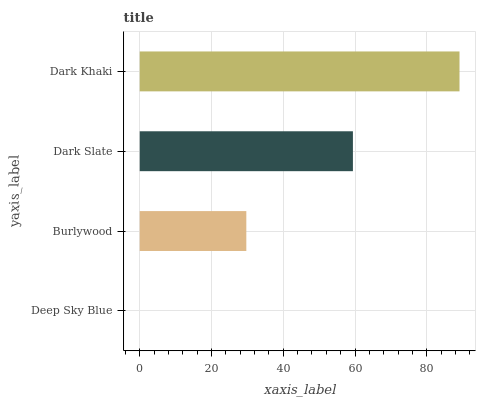Is Deep Sky Blue the minimum?
Answer yes or no. Yes. Is Dark Khaki the maximum?
Answer yes or no. Yes. Is Burlywood the minimum?
Answer yes or no. No. Is Burlywood the maximum?
Answer yes or no. No. Is Burlywood greater than Deep Sky Blue?
Answer yes or no. Yes. Is Deep Sky Blue less than Burlywood?
Answer yes or no. Yes. Is Deep Sky Blue greater than Burlywood?
Answer yes or no. No. Is Burlywood less than Deep Sky Blue?
Answer yes or no. No. Is Dark Slate the high median?
Answer yes or no. Yes. Is Burlywood the low median?
Answer yes or no. Yes. Is Deep Sky Blue the high median?
Answer yes or no. No. Is Dark Slate the low median?
Answer yes or no. No. 